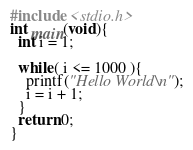Convert code to text. <code><loc_0><loc_0><loc_500><loc_500><_C_>#include <stdio.h>
int main(void){
  int i = 1;

  while( i <= 1000 ){
    printf("Hello World\n");
    i = i + 1;
  }
  return 0;
}</code> 